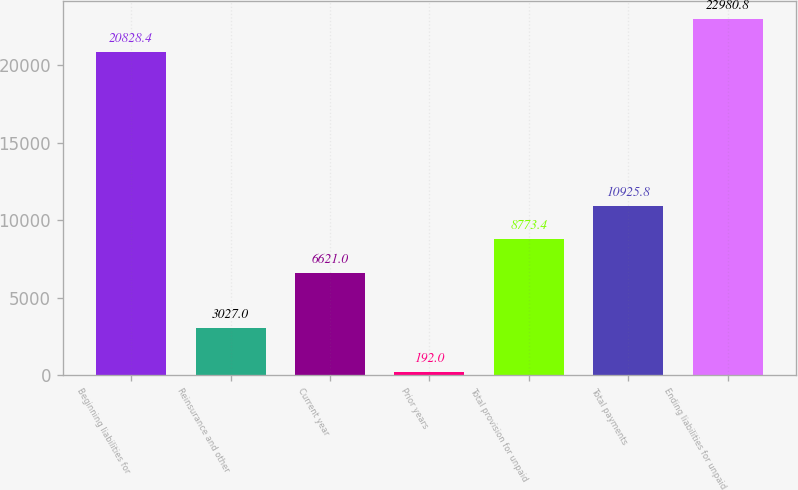Convert chart. <chart><loc_0><loc_0><loc_500><loc_500><bar_chart><fcel>Beginning liabilities for<fcel>Reinsurance and other<fcel>Current year<fcel>Prior years<fcel>Total provision for unpaid<fcel>Total payments<fcel>Ending liabilities for unpaid<nl><fcel>20828.4<fcel>3027<fcel>6621<fcel>192<fcel>8773.4<fcel>10925.8<fcel>22980.8<nl></chart> 